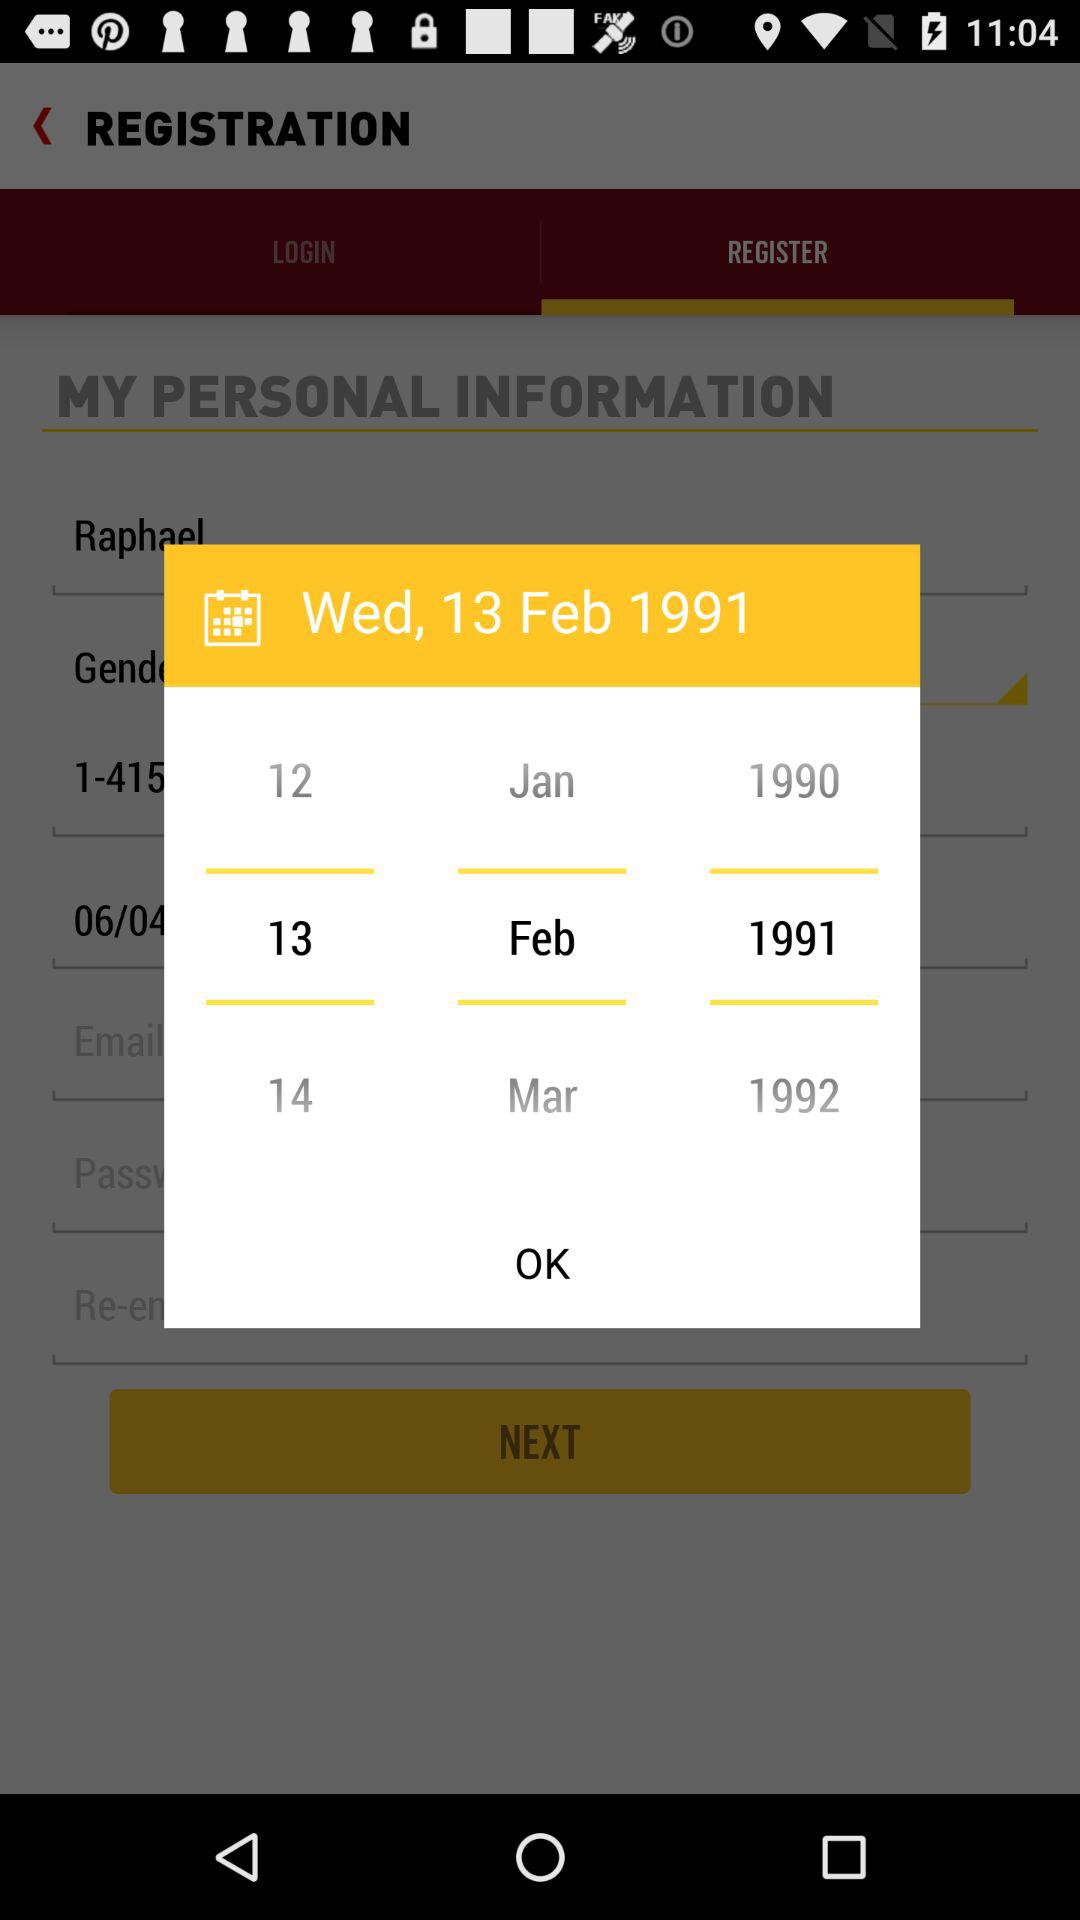What are the different available dates? The different available dates are January 12, 1990; February 13, 1991 and March 14, 1992. 